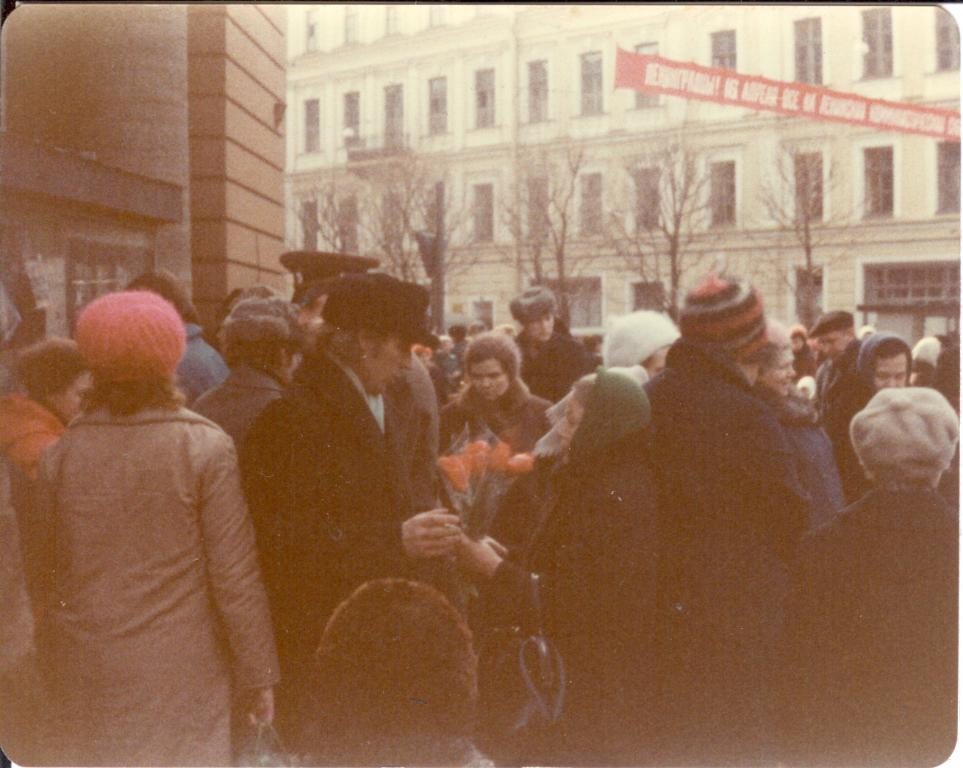How many people are visible in the foreground of the image? There are many people in the foreground of the image. What can be seen in the background of the image? There are buildings and trees in the background of the image. What type of lizards can be seen crawling on the buildings in the image? There are no lizards present in the image; only people, buildings, and trees are visible. What sound does the alarm make in the image? There is no alarm present in the image, so it is not possible to determine the sound it would make. 